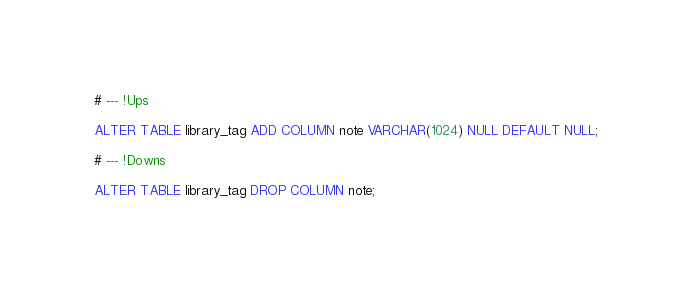Convert code to text. <code><loc_0><loc_0><loc_500><loc_500><_SQL_># --- !Ups

ALTER TABLE library_tag ADD COLUMN note VARCHAR(1024) NULL DEFAULT NULL;

# --- !Downs

ALTER TABLE library_tag DROP COLUMN note;
</code> 